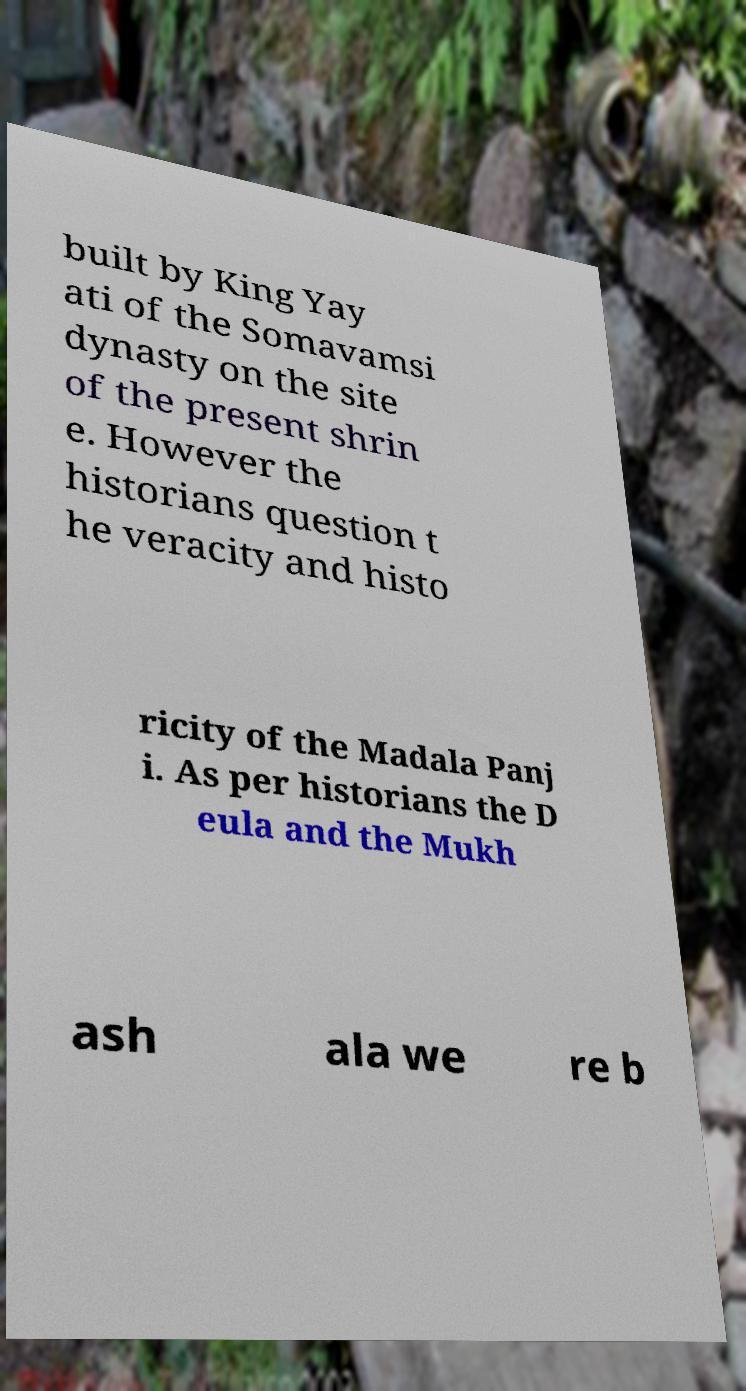Please identify and transcribe the text found in this image. built by King Yay ati of the Somavamsi dynasty on the site of the present shrin e. However the historians question t he veracity and histo ricity of the Madala Panj i. As per historians the D eula and the Mukh ash ala we re b 